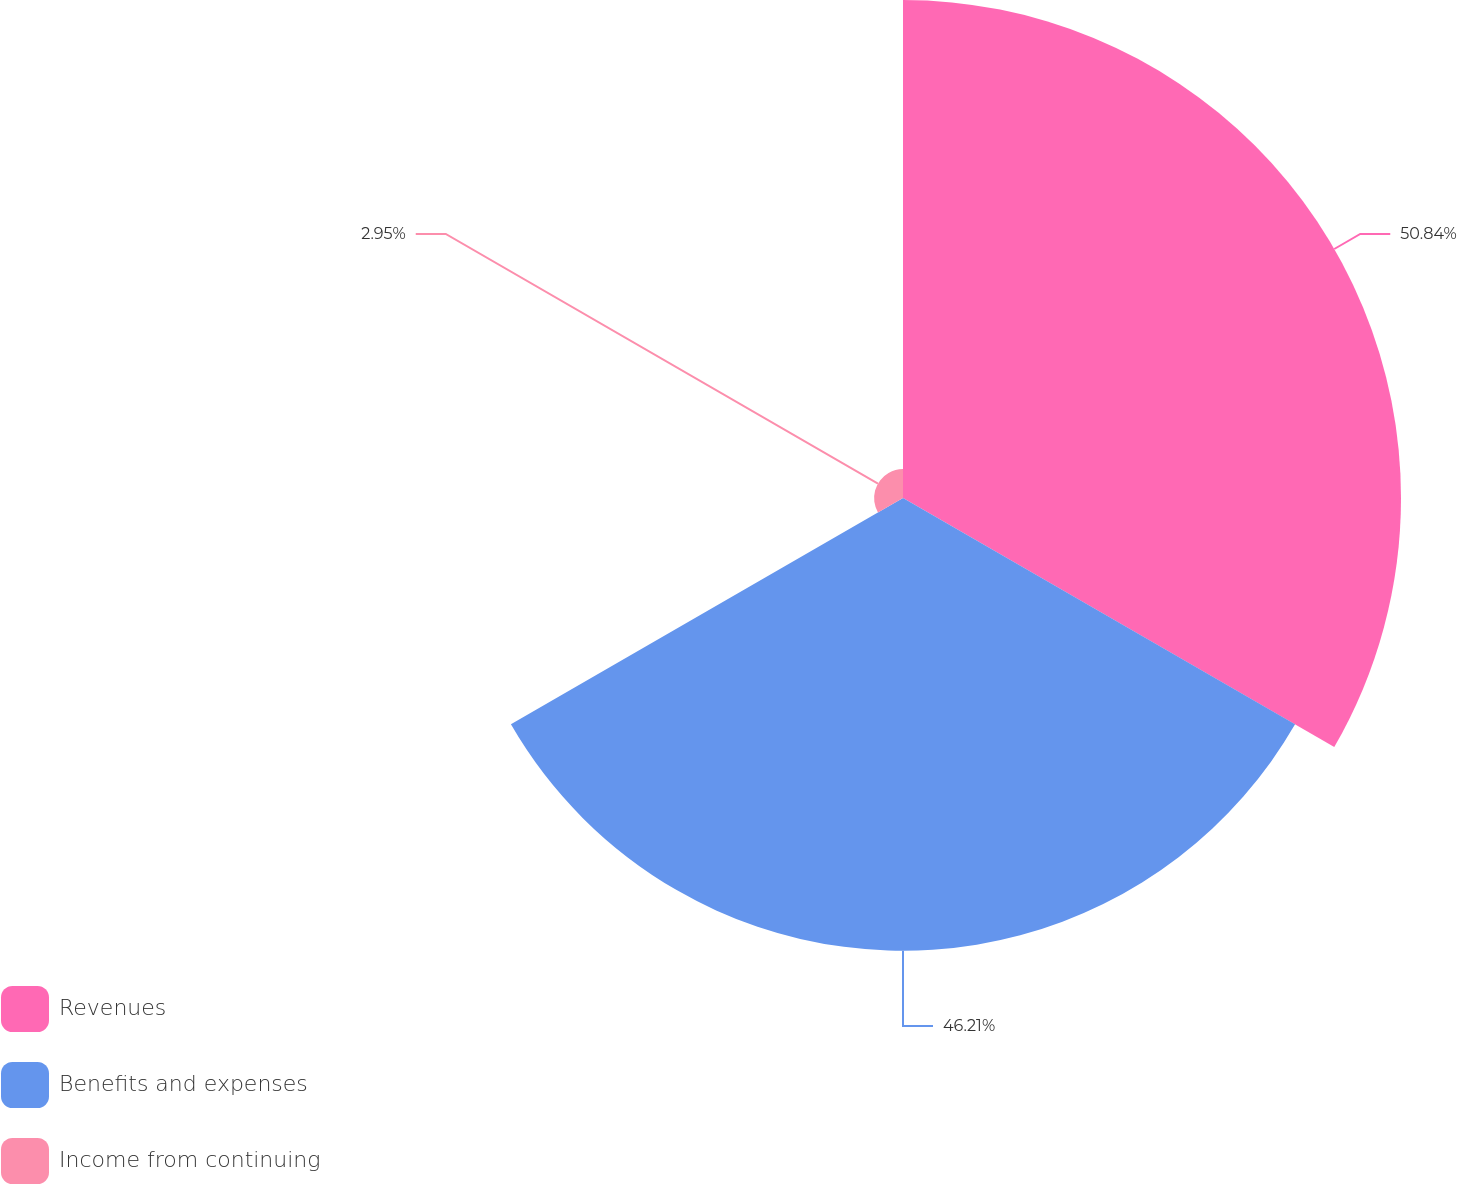Convert chart to OTSL. <chart><loc_0><loc_0><loc_500><loc_500><pie_chart><fcel>Revenues<fcel>Benefits and expenses<fcel>Income from continuing<nl><fcel>50.83%<fcel>46.21%<fcel>2.95%<nl></chart> 